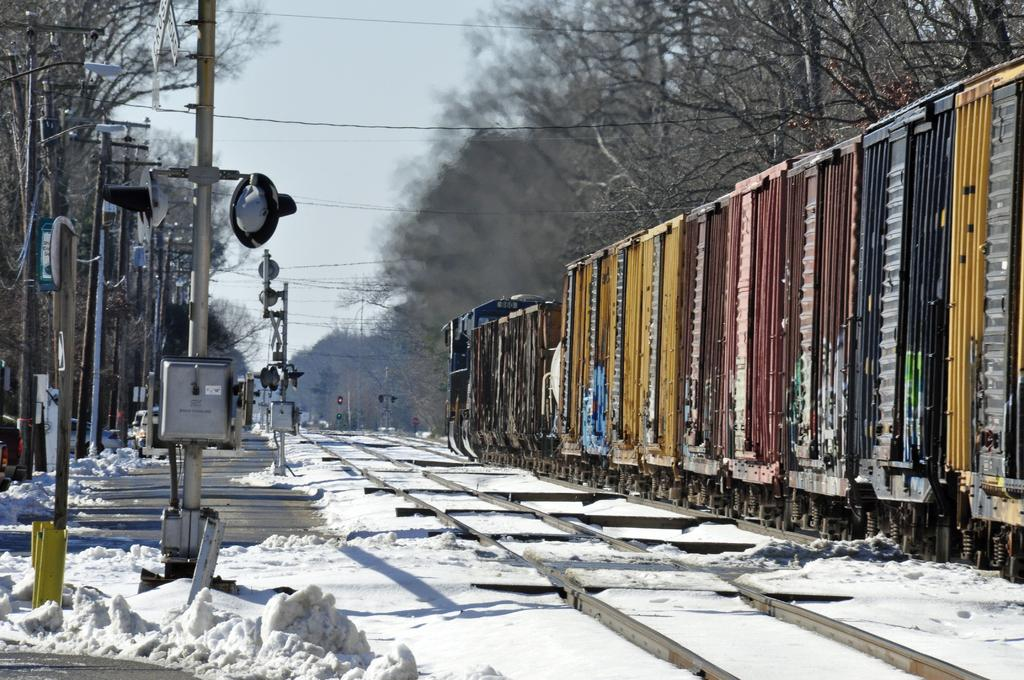What type of vegetation can be seen on the right side of the image? There are trees on the right side of the image. What mode of transportation is present on the right side of the image? There is a train on the right side of the image. What structures can be seen in the image? There are cables, railway tracks, poles, and street lights visible in the image. What natural element is present in the image? There is ice visible in the image. What is the condition of the sky in the image? The sky is visible in the image. Who is the owner of the apparatus visible in the image? There is no apparatus present in the image. Are there any fairies visible in the image? There are no fairies present in the image. 